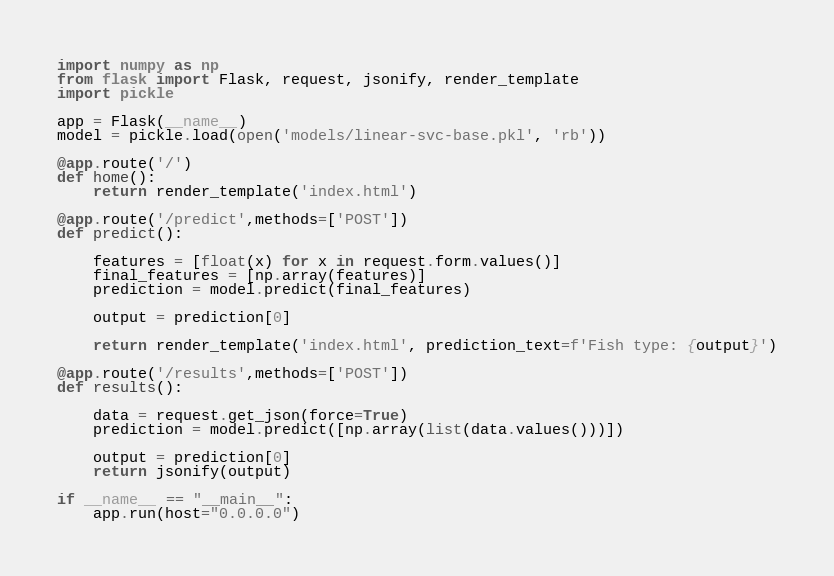Convert code to text. <code><loc_0><loc_0><loc_500><loc_500><_Python_>import numpy as np
from flask import Flask, request, jsonify, render_template
import pickle

app = Flask(__name__)
model = pickle.load(open('models/linear-svc-base.pkl', 'rb'))

@app.route('/')
def home():
    return render_template('index.html')

@app.route('/predict',methods=['POST'])
def predict():

    features = [float(x) for x in request.form.values()]
    final_features = [np.array(features)]
    prediction = model.predict(final_features)

    output = prediction[0]

    return render_template('index.html', prediction_text=f'Fish type: {output}')

@app.route('/results',methods=['POST'])
def results():

    data = request.get_json(force=True)
    prediction = model.predict([np.array(list(data.values()))])

    output = prediction[0]
    return jsonify(output)

if __name__ == "__main__":
    app.run(host="0.0.0.0")</code> 